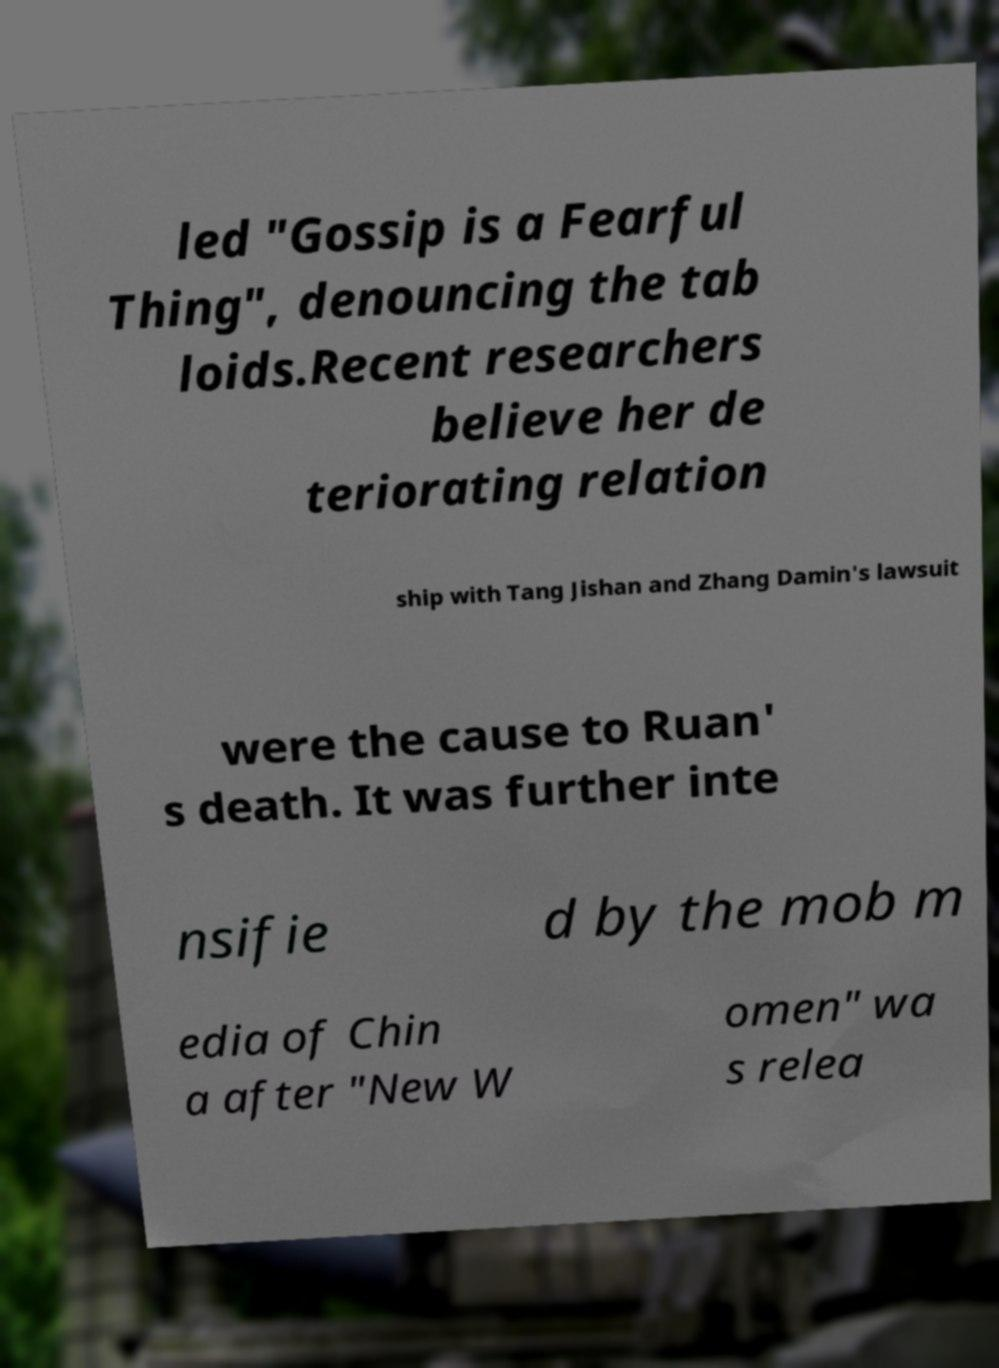Can you accurately transcribe the text from the provided image for me? led "Gossip is a Fearful Thing", denouncing the tab loids.Recent researchers believe her de teriorating relation ship with Tang Jishan and Zhang Damin's lawsuit were the cause to Ruan' s death. It was further inte nsifie d by the mob m edia of Chin a after "New W omen" wa s relea 